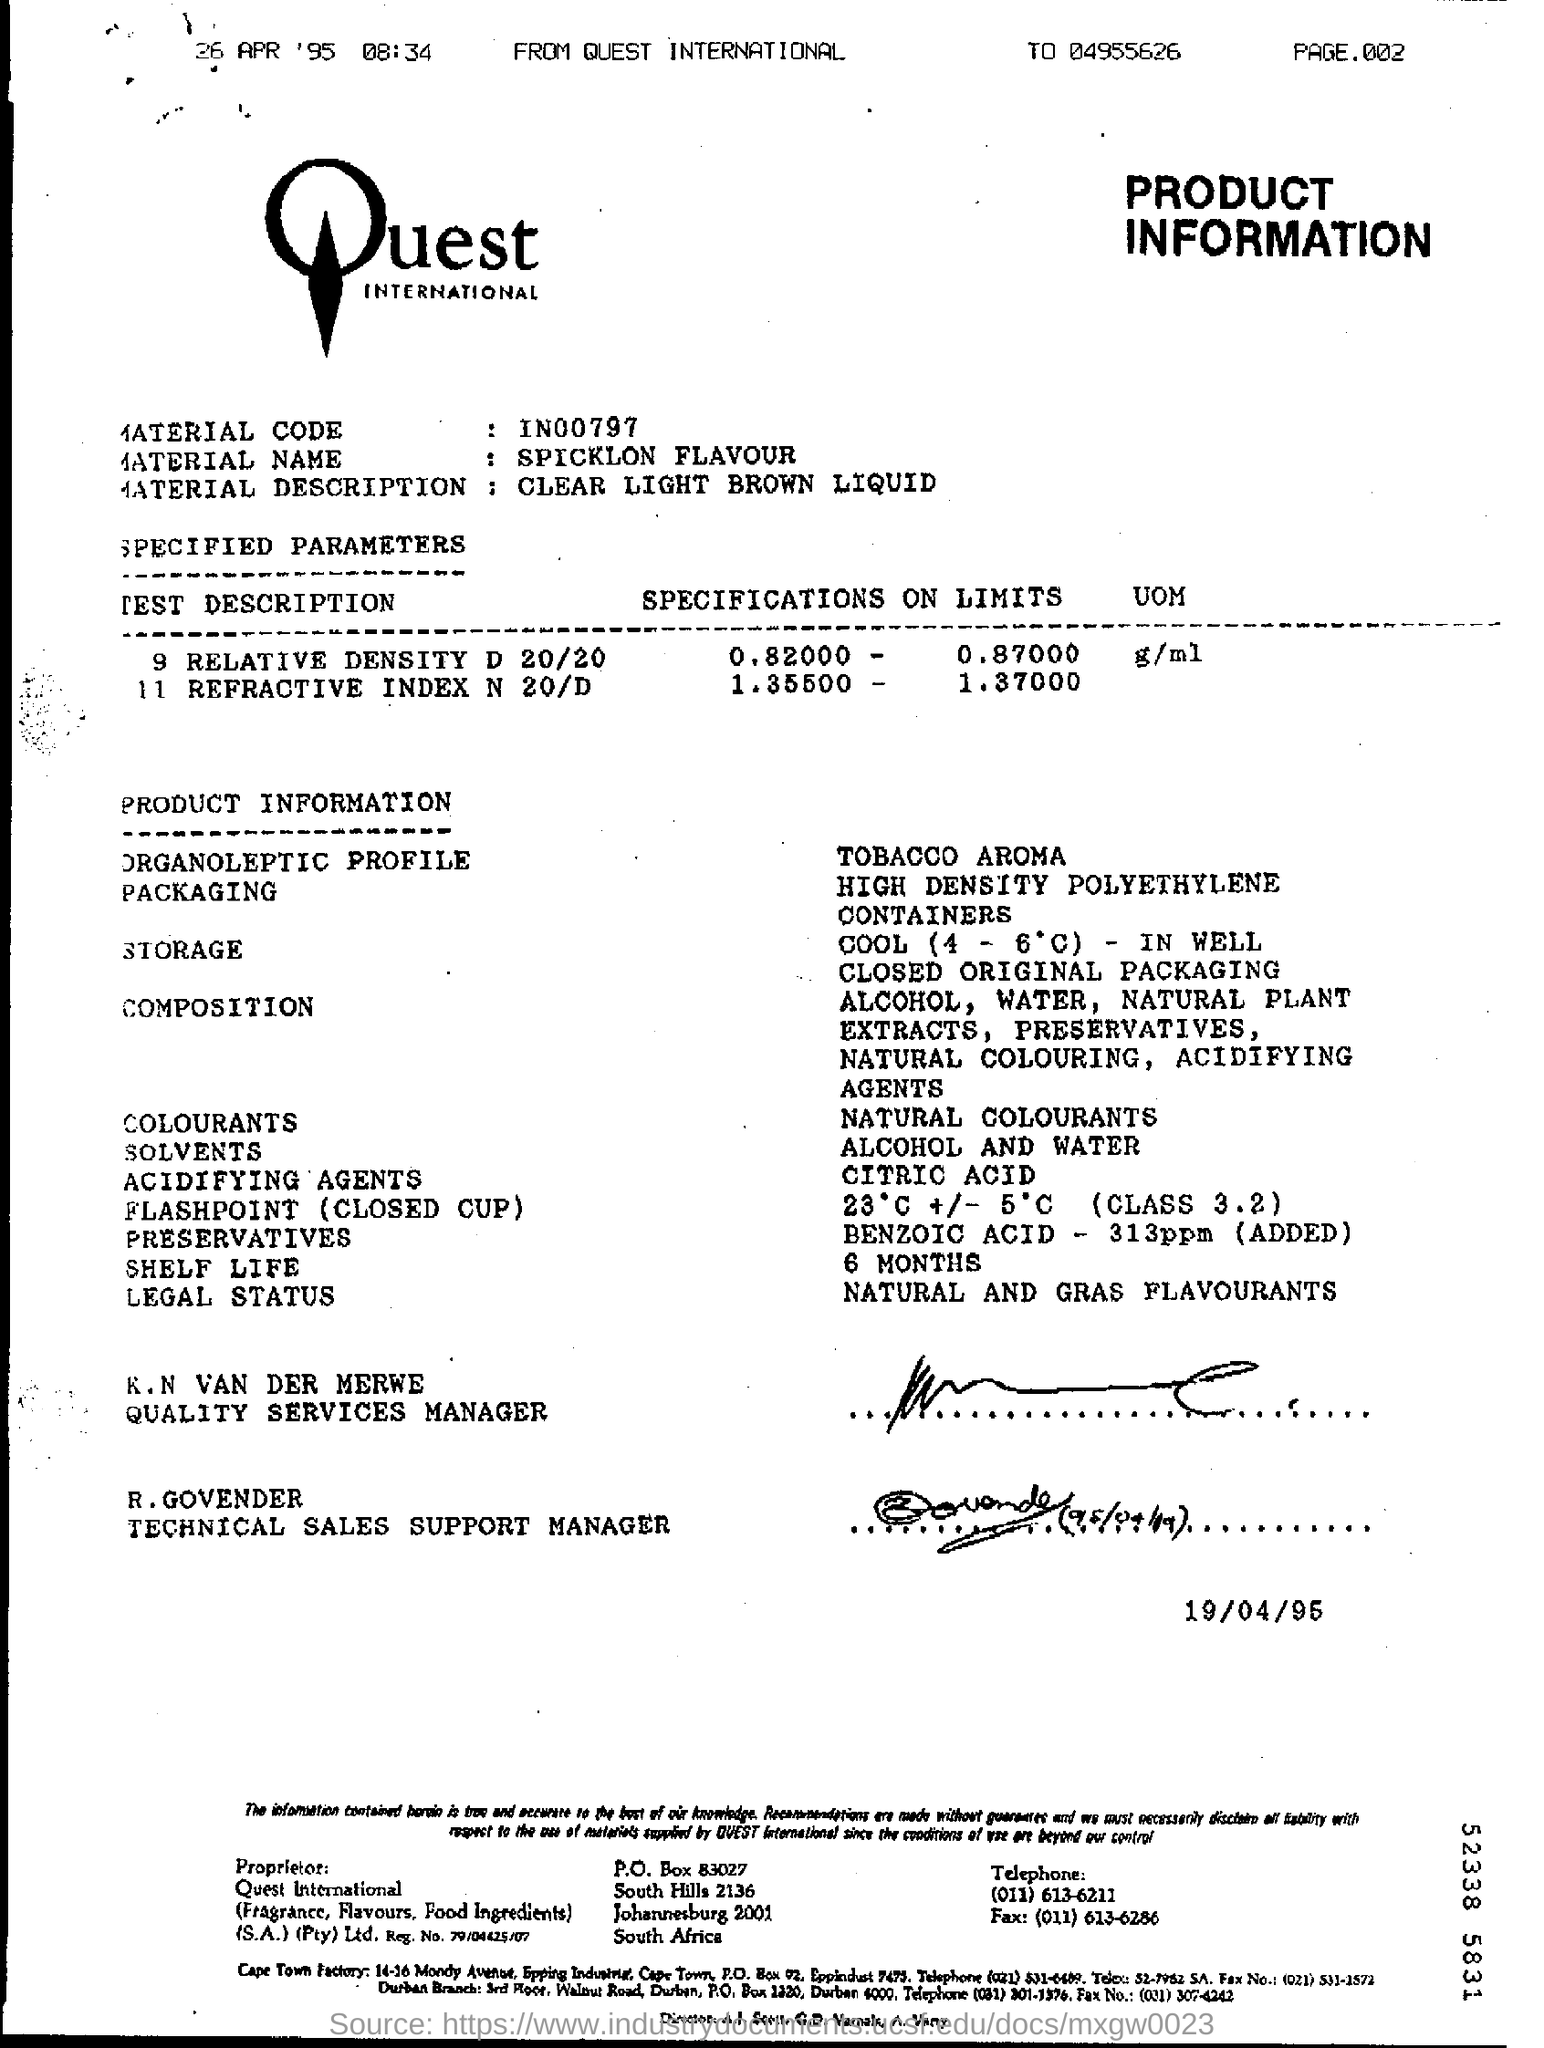Identify some key points in this picture. Our product uses natural colorants in its formulation. The material name listed in the document is Spicklon Flavour. This product uses citric acid as an acidifying agent. R. GOVENDER is a Technical Sales Support Manager who specializes in providing support to technical teams. The given information pertains to the product of Quest International. 